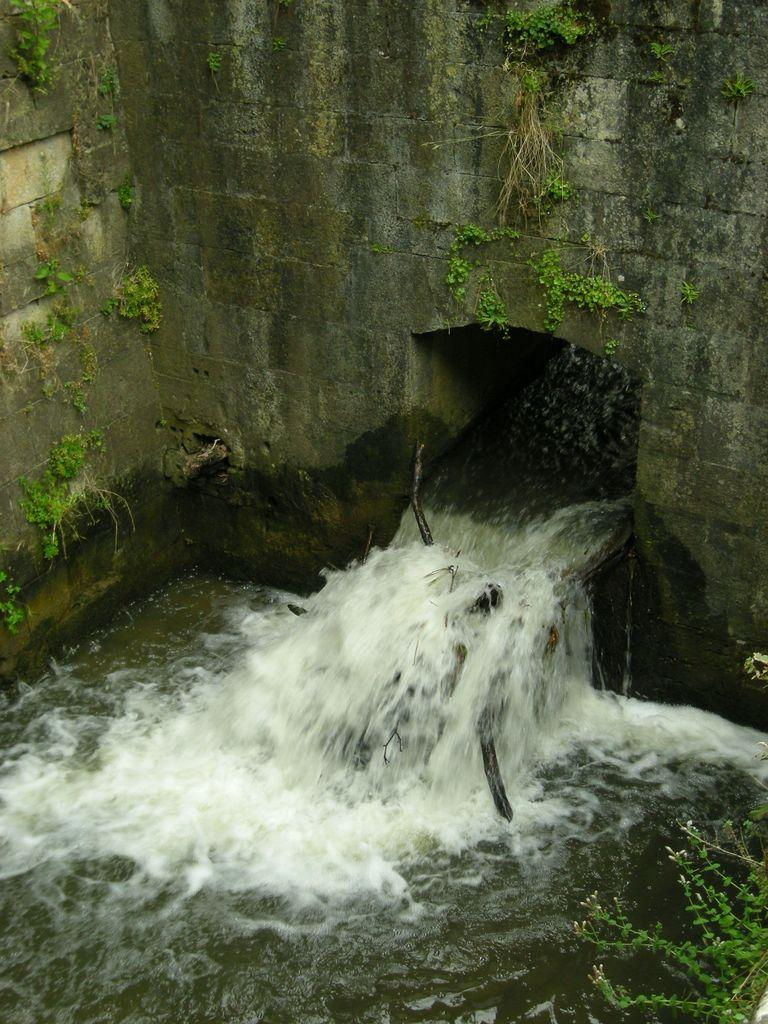What is the main feature in the foreground of the image? There is a hole in the wall in the foreground of the image. What is happening with the water in the image? Water is flowing through the hole in the wall. Where is the plant located in the image? There is a plant in the right bottom corner of the image. What else can be seen on the wall in the image? There are plants on the wall in the image. What type of behavior is the mitten exhibiting in the image? There is no mitten present in the image, so it is not possible to determine its behavior. How does the soap interact with the water in the image? There is no soap present in the image, so it is not possible to determine its interaction with the water. 